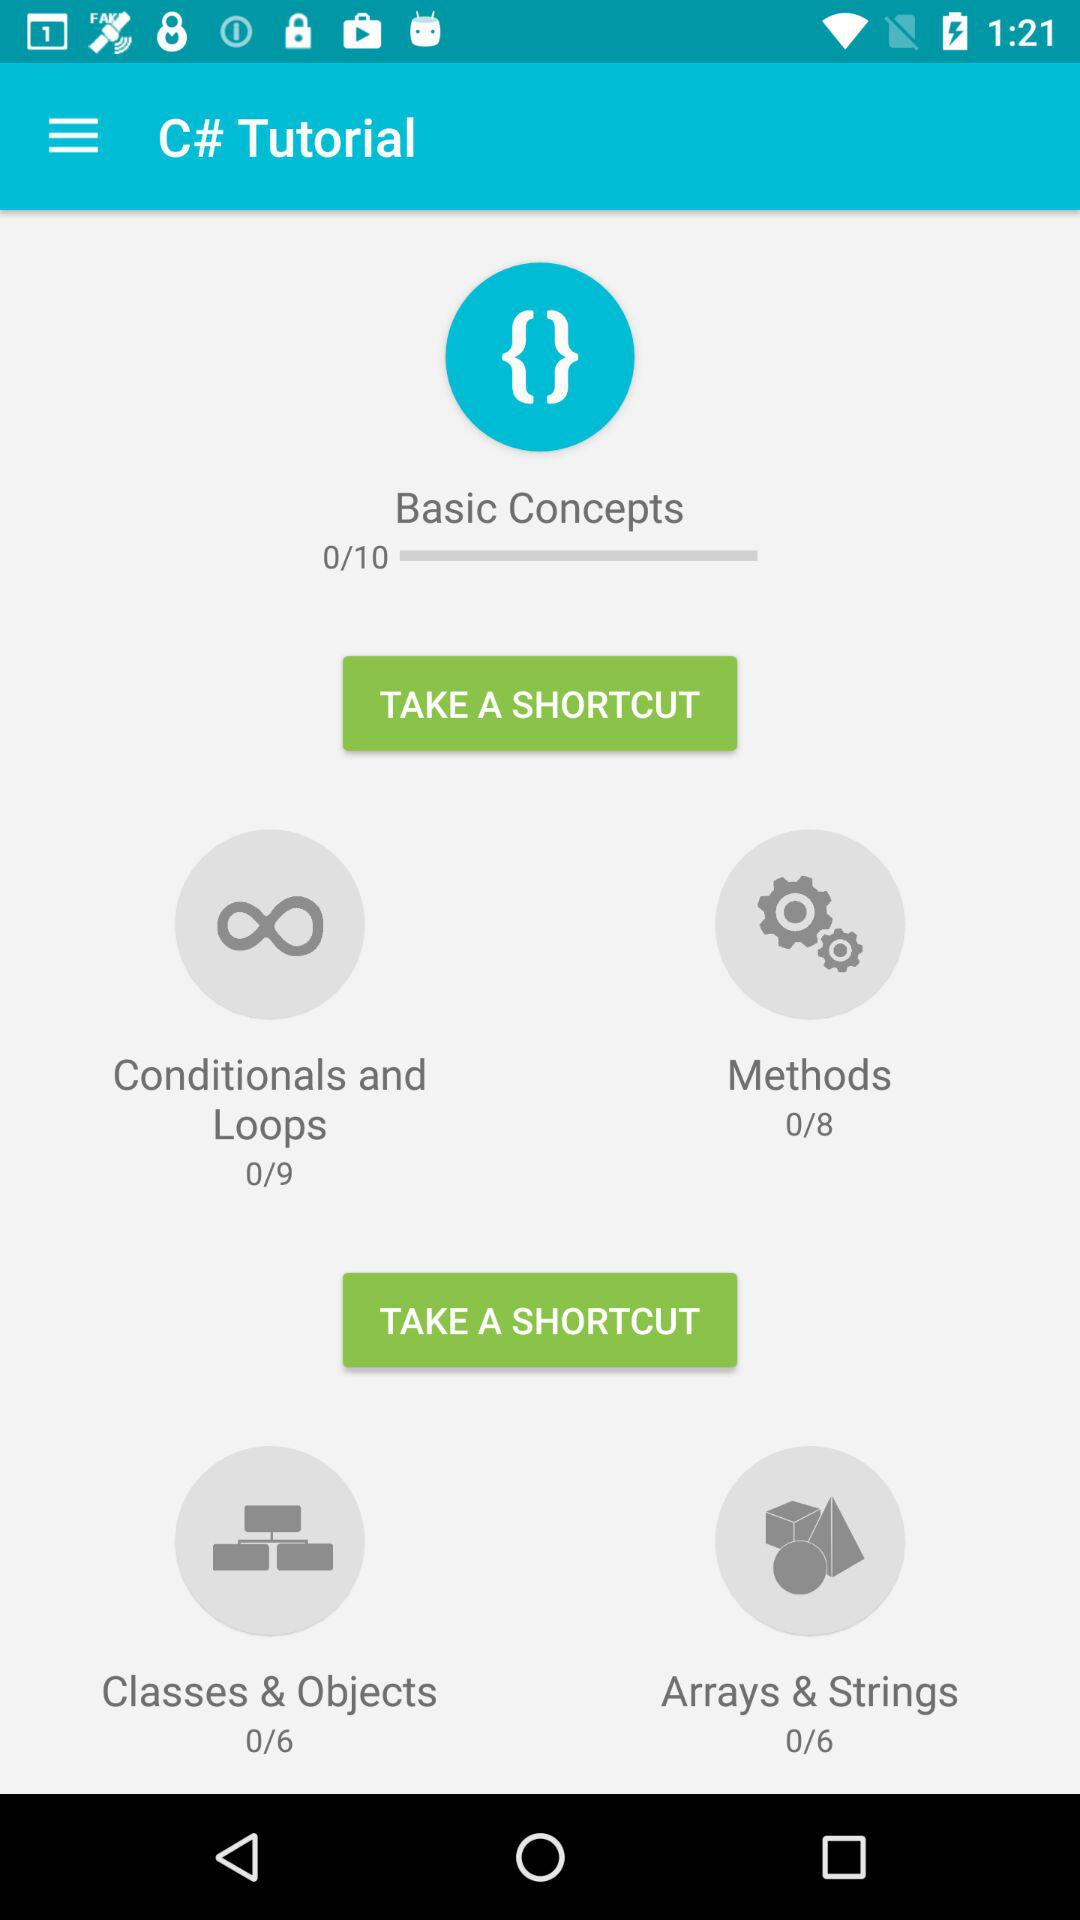How many modules in "Basic Concepts" in total are there? There are 10 modules in "Basic Concepts" in total. 